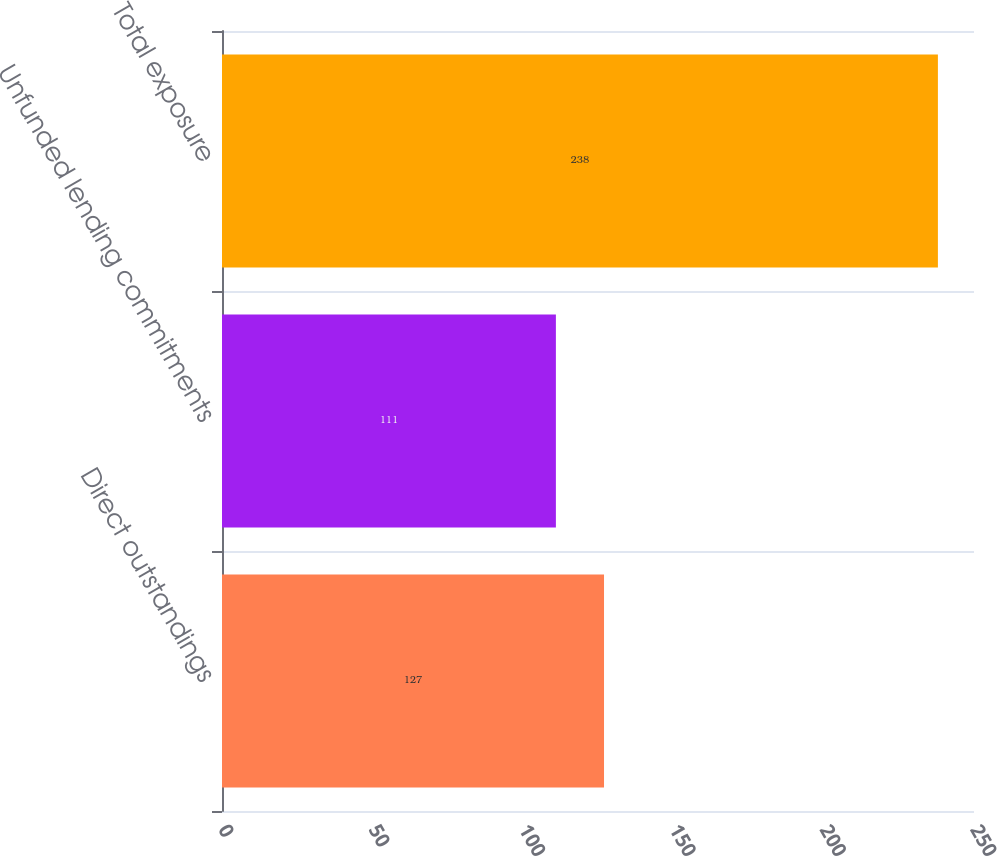Convert chart to OTSL. <chart><loc_0><loc_0><loc_500><loc_500><bar_chart><fcel>Direct outstandings<fcel>Unfunded lending commitments<fcel>Total exposure<nl><fcel>127<fcel>111<fcel>238<nl></chart> 